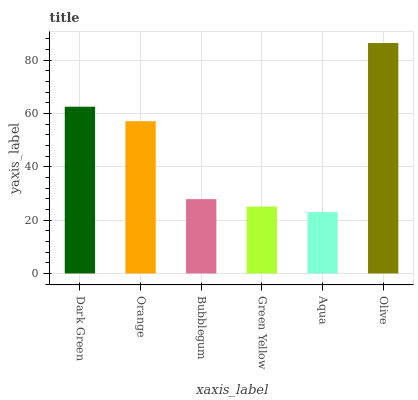Is Orange the minimum?
Answer yes or no. No. Is Orange the maximum?
Answer yes or no. No. Is Dark Green greater than Orange?
Answer yes or no. Yes. Is Orange less than Dark Green?
Answer yes or no. Yes. Is Orange greater than Dark Green?
Answer yes or no. No. Is Dark Green less than Orange?
Answer yes or no. No. Is Orange the high median?
Answer yes or no. Yes. Is Bubblegum the low median?
Answer yes or no. Yes. Is Bubblegum the high median?
Answer yes or no. No. Is Olive the low median?
Answer yes or no. No. 